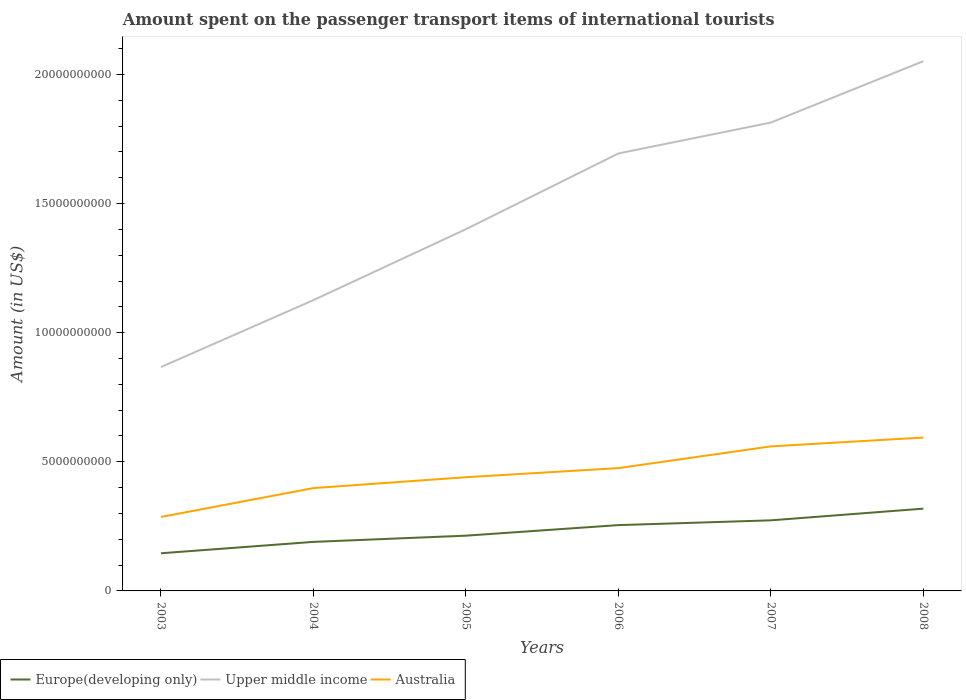Is the number of lines equal to the number of legend labels?
Your answer should be compact. Yes. Across all years, what is the maximum amount spent on the passenger transport items of international tourists in Upper middle income?
Your response must be concise. 8.67e+09. What is the total amount spent on the passenger transport items of international tourists in Australia in the graph?
Offer a very short reply. -1.12e+09. What is the difference between the highest and the second highest amount spent on the passenger transport items of international tourists in Australia?
Make the answer very short. 3.08e+09. Is the amount spent on the passenger transport items of international tourists in Europe(developing only) strictly greater than the amount spent on the passenger transport items of international tourists in Upper middle income over the years?
Keep it short and to the point. Yes. What is the difference between two consecutive major ticks on the Y-axis?
Your answer should be compact. 5.00e+09. Does the graph contain grids?
Provide a short and direct response. No. How many legend labels are there?
Provide a succinct answer. 3. What is the title of the graph?
Ensure brevity in your answer.  Amount spent on the passenger transport items of international tourists. What is the label or title of the X-axis?
Give a very brief answer. Years. What is the Amount (in US$) of Europe(developing only) in 2003?
Give a very brief answer. 1.46e+09. What is the Amount (in US$) of Upper middle income in 2003?
Provide a short and direct response. 8.67e+09. What is the Amount (in US$) in Australia in 2003?
Offer a very short reply. 2.86e+09. What is the Amount (in US$) of Europe(developing only) in 2004?
Keep it short and to the point. 1.90e+09. What is the Amount (in US$) of Upper middle income in 2004?
Ensure brevity in your answer.  1.13e+1. What is the Amount (in US$) in Australia in 2004?
Your answer should be very brief. 3.98e+09. What is the Amount (in US$) in Europe(developing only) in 2005?
Ensure brevity in your answer.  2.14e+09. What is the Amount (in US$) in Upper middle income in 2005?
Your response must be concise. 1.40e+1. What is the Amount (in US$) of Australia in 2005?
Ensure brevity in your answer.  4.40e+09. What is the Amount (in US$) of Europe(developing only) in 2006?
Offer a very short reply. 2.55e+09. What is the Amount (in US$) in Upper middle income in 2006?
Provide a succinct answer. 1.69e+1. What is the Amount (in US$) of Australia in 2006?
Your response must be concise. 4.76e+09. What is the Amount (in US$) in Europe(developing only) in 2007?
Provide a short and direct response. 2.73e+09. What is the Amount (in US$) of Upper middle income in 2007?
Provide a succinct answer. 1.81e+1. What is the Amount (in US$) in Australia in 2007?
Your answer should be compact. 5.60e+09. What is the Amount (in US$) of Europe(developing only) in 2008?
Your answer should be compact. 3.19e+09. What is the Amount (in US$) of Upper middle income in 2008?
Give a very brief answer. 2.05e+1. What is the Amount (in US$) in Australia in 2008?
Offer a very short reply. 5.94e+09. Across all years, what is the maximum Amount (in US$) in Europe(developing only)?
Provide a short and direct response. 3.19e+09. Across all years, what is the maximum Amount (in US$) in Upper middle income?
Your answer should be compact. 2.05e+1. Across all years, what is the maximum Amount (in US$) in Australia?
Your answer should be compact. 5.94e+09. Across all years, what is the minimum Amount (in US$) of Europe(developing only)?
Make the answer very short. 1.46e+09. Across all years, what is the minimum Amount (in US$) in Upper middle income?
Your response must be concise. 8.67e+09. Across all years, what is the minimum Amount (in US$) in Australia?
Provide a short and direct response. 2.86e+09. What is the total Amount (in US$) of Europe(developing only) in the graph?
Provide a succinct answer. 1.40e+1. What is the total Amount (in US$) in Upper middle income in the graph?
Give a very brief answer. 8.95e+1. What is the total Amount (in US$) of Australia in the graph?
Give a very brief answer. 2.75e+1. What is the difference between the Amount (in US$) in Europe(developing only) in 2003 and that in 2004?
Your answer should be very brief. -4.41e+08. What is the difference between the Amount (in US$) in Upper middle income in 2003 and that in 2004?
Provide a short and direct response. -2.59e+09. What is the difference between the Amount (in US$) of Australia in 2003 and that in 2004?
Make the answer very short. -1.12e+09. What is the difference between the Amount (in US$) in Europe(developing only) in 2003 and that in 2005?
Offer a terse response. -6.81e+08. What is the difference between the Amount (in US$) in Upper middle income in 2003 and that in 2005?
Keep it short and to the point. -5.34e+09. What is the difference between the Amount (in US$) of Australia in 2003 and that in 2005?
Provide a short and direct response. -1.54e+09. What is the difference between the Amount (in US$) of Europe(developing only) in 2003 and that in 2006?
Offer a very short reply. -1.09e+09. What is the difference between the Amount (in US$) of Upper middle income in 2003 and that in 2006?
Your response must be concise. -8.27e+09. What is the difference between the Amount (in US$) of Australia in 2003 and that in 2006?
Your answer should be very brief. -1.89e+09. What is the difference between the Amount (in US$) of Europe(developing only) in 2003 and that in 2007?
Make the answer very short. -1.28e+09. What is the difference between the Amount (in US$) of Upper middle income in 2003 and that in 2007?
Provide a succinct answer. -9.47e+09. What is the difference between the Amount (in US$) of Australia in 2003 and that in 2007?
Make the answer very short. -2.73e+09. What is the difference between the Amount (in US$) in Europe(developing only) in 2003 and that in 2008?
Offer a terse response. -1.73e+09. What is the difference between the Amount (in US$) in Upper middle income in 2003 and that in 2008?
Provide a succinct answer. -1.18e+1. What is the difference between the Amount (in US$) of Australia in 2003 and that in 2008?
Give a very brief answer. -3.08e+09. What is the difference between the Amount (in US$) of Europe(developing only) in 2004 and that in 2005?
Provide a short and direct response. -2.40e+08. What is the difference between the Amount (in US$) of Upper middle income in 2004 and that in 2005?
Offer a very short reply. -2.75e+09. What is the difference between the Amount (in US$) of Australia in 2004 and that in 2005?
Your answer should be compact. -4.22e+08. What is the difference between the Amount (in US$) in Europe(developing only) in 2004 and that in 2006?
Offer a terse response. -6.49e+08. What is the difference between the Amount (in US$) in Upper middle income in 2004 and that in 2006?
Make the answer very short. -5.68e+09. What is the difference between the Amount (in US$) of Australia in 2004 and that in 2006?
Keep it short and to the point. -7.74e+08. What is the difference between the Amount (in US$) of Europe(developing only) in 2004 and that in 2007?
Ensure brevity in your answer.  -8.34e+08. What is the difference between the Amount (in US$) of Upper middle income in 2004 and that in 2007?
Your answer should be very brief. -6.88e+09. What is the difference between the Amount (in US$) of Australia in 2004 and that in 2007?
Offer a terse response. -1.62e+09. What is the difference between the Amount (in US$) of Europe(developing only) in 2004 and that in 2008?
Provide a short and direct response. -1.29e+09. What is the difference between the Amount (in US$) of Upper middle income in 2004 and that in 2008?
Your response must be concise. -9.25e+09. What is the difference between the Amount (in US$) of Australia in 2004 and that in 2008?
Provide a succinct answer. -1.96e+09. What is the difference between the Amount (in US$) of Europe(developing only) in 2005 and that in 2006?
Offer a terse response. -4.09e+08. What is the difference between the Amount (in US$) in Upper middle income in 2005 and that in 2006?
Your answer should be very brief. -2.93e+09. What is the difference between the Amount (in US$) of Australia in 2005 and that in 2006?
Keep it short and to the point. -3.52e+08. What is the difference between the Amount (in US$) of Europe(developing only) in 2005 and that in 2007?
Your response must be concise. -5.94e+08. What is the difference between the Amount (in US$) in Upper middle income in 2005 and that in 2007?
Your response must be concise. -4.13e+09. What is the difference between the Amount (in US$) in Australia in 2005 and that in 2007?
Offer a terse response. -1.19e+09. What is the difference between the Amount (in US$) of Europe(developing only) in 2005 and that in 2008?
Provide a succinct answer. -1.05e+09. What is the difference between the Amount (in US$) in Upper middle income in 2005 and that in 2008?
Provide a succinct answer. -6.51e+09. What is the difference between the Amount (in US$) in Australia in 2005 and that in 2008?
Provide a short and direct response. -1.54e+09. What is the difference between the Amount (in US$) in Europe(developing only) in 2006 and that in 2007?
Your answer should be very brief. -1.85e+08. What is the difference between the Amount (in US$) of Upper middle income in 2006 and that in 2007?
Ensure brevity in your answer.  -1.20e+09. What is the difference between the Amount (in US$) in Australia in 2006 and that in 2007?
Your response must be concise. -8.42e+08. What is the difference between the Amount (in US$) in Europe(developing only) in 2006 and that in 2008?
Make the answer very short. -6.38e+08. What is the difference between the Amount (in US$) of Upper middle income in 2006 and that in 2008?
Provide a short and direct response. -3.57e+09. What is the difference between the Amount (in US$) in Australia in 2006 and that in 2008?
Offer a very short reply. -1.18e+09. What is the difference between the Amount (in US$) in Europe(developing only) in 2007 and that in 2008?
Ensure brevity in your answer.  -4.53e+08. What is the difference between the Amount (in US$) of Upper middle income in 2007 and that in 2008?
Provide a succinct answer. -2.38e+09. What is the difference between the Amount (in US$) in Australia in 2007 and that in 2008?
Provide a short and direct response. -3.42e+08. What is the difference between the Amount (in US$) in Europe(developing only) in 2003 and the Amount (in US$) in Upper middle income in 2004?
Your response must be concise. -9.80e+09. What is the difference between the Amount (in US$) in Europe(developing only) in 2003 and the Amount (in US$) in Australia in 2004?
Provide a succinct answer. -2.52e+09. What is the difference between the Amount (in US$) of Upper middle income in 2003 and the Amount (in US$) of Australia in 2004?
Provide a succinct answer. 4.69e+09. What is the difference between the Amount (in US$) of Europe(developing only) in 2003 and the Amount (in US$) of Upper middle income in 2005?
Ensure brevity in your answer.  -1.26e+1. What is the difference between the Amount (in US$) of Europe(developing only) in 2003 and the Amount (in US$) of Australia in 2005?
Your answer should be very brief. -2.95e+09. What is the difference between the Amount (in US$) of Upper middle income in 2003 and the Amount (in US$) of Australia in 2005?
Keep it short and to the point. 4.27e+09. What is the difference between the Amount (in US$) of Europe(developing only) in 2003 and the Amount (in US$) of Upper middle income in 2006?
Provide a short and direct response. -1.55e+1. What is the difference between the Amount (in US$) of Europe(developing only) in 2003 and the Amount (in US$) of Australia in 2006?
Offer a terse response. -3.30e+09. What is the difference between the Amount (in US$) in Upper middle income in 2003 and the Amount (in US$) in Australia in 2006?
Offer a very short reply. 3.91e+09. What is the difference between the Amount (in US$) in Europe(developing only) in 2003 and the Amount (in US$) in Upper middle income in 2007?
Give a very brief answer. -1.67e+1. What is the difference between the Amount (in US$) of Europe(developing only) in 2003 and the Amount (in US$) of Australia in 2007?
Keep it short and to the point. -4.14e+09. What is the difference between the Amount (in US$) of Upper middle income in 2003 and the Amount (in US$) of Australia in 2007?
Your response must be concise. 3.07e+09. What is the difference between the Amount (in US$) in Europe(developing only) in 2003 and the Amount (in US$) in Upper middle income in 2008?
Your answer should be very brief. -1.91e+1. What is the difference between the Amount (in US$) in Europe(developing only) in 2003 and the Amount (in US$) in Australia in 2008?
Give a very brief answer. -4.48e+09. What is the difference between the Amount (in US$) of Upper middle income in 2003 and the Amount (in US$) of Australia in 2008?
Ensure brevity in your answer.  2.73e+09. What is the difference between the Amount (in US$) of Europe(developing only) in 2004 and the Amount (in US$) of Upper middle income in 2005?
Provide a short and direct response. -1.21e+1. What is the difference between the Amount (in US$) of Europe(developing only) in 2004 and the Amount (in US$) of Australia in 2005?
Offer a very short reply. -2.50e+09. What is the difference between the Amount (in US$) of Upper middle income in 2004 and the Amount (in US$) of Australia in 2005?
Your response must be concise. 6.86e+09. What is the difference between the Amount (in US$) of Europe(developing only) in 2004 and the Amount (in US$) of Upper middle income in 2006?
Offer a terse response. -1.50e+1. What is the difference between the Amount (in US$) in Europe(developing only) in 2004 and the Amount (in US$) in Australia in 2006?
Offer a terse response. -2.86e+09. What is the difference between the Amount (in US$) of Upper middle income in 2004 and the Amount (in US$) of Australia in 2006?
Keep it short and to the point. 6.51e+09. What is the difference between the Amount (in US$) in Europe(developing only) in 2004 and the Amount (in US$) in Upper middle income in 2007?
Provide a succinct answer. -1.62e+1. What is the difference between the Amount (in US$) in Europe(developing only) in 2004 and the Amount (in US$) in Australia in 2007?
Offer a very short reply. -3.70e+09. What is the difference between the Amount (in US$) in Upper middle income in 2004 and the Amount (in US$) in Australia in 2007?
Your answer should be very brief. 5.66e+09. What is the difference between the Amount (in US$) in Europe(developing only) in 2004 and the Amount (in US$) in Upper middle income in 2008?
Make the answer very short. -1.86e+1. What is the difference between the Amount (in US$) in Europe(developing only) in 2004 and the Amount (in US$) in Australia in 2008?
Your answer should be compact. -4.04e+09. What is the difference between the Amount (in US$) of Upper middle income in 2004 and the Amount (in US$) of Australia in 2008?
Your answer should be compact. 5.32e+09. What is the difference between the Amount (in US$) of Europe(developing only) in 2005 and the Amount (in US$) of Upper middle income in 2006?
Your answer should be very brief. -1.48e+1. What is the difference between the Amount (in US$) in Europe(developing only) in 2005 and the Amount (in US$) in Australia in 2006?
Provide a succinct answer. -2.62e+09. What is the difference between the Amount (in US$) in Upper middle income in 2005 and the Amount (in US$) in Australia in 2006?
Make the answer very short. 9.25e+09. What is the difference between the Amount (in US$) of Europe(developing only) in 2005 and the Amount (in US$) of Upper middle income in 2007?
Ensure brevity in your answer.  -1.60e+1. What is the difference between the Amount (in US$) in Europe(developing only) in 2005 and the Amount (in US$) in Australia in 2007?
Keep it short and to the point. -3.46e+09. What is the difference between the Amount (in US$) in Upper middle income in 2005 and the Amount (in US$) in Australia in 2007?
Keep it short and to the point. 8.41e+09. What is the difference between the Amount (in US$) of Europe(developing only) in 2005 and the Amount (in US$) of Upper middle income in 2008?
Your response must be concise. -1.84e+1. What is the difference between the Amount (in US$) of Europe(developing only) in 2005 and the Amount (in US$) of Australia in 2008?
Offer a terse response. -3.80e+09. What is the difference between the Amount (in US$) of Upper middle income in 2005 and the Amount (in US$) of Australia in 2008?
Offer a very short reply. 8.07e+09. What is the difference between the Amount (in US$) in Europe(developing only) in 2006 and the Amount (in US$) in Upper middle income in 2007?
Your answer should be very brief. -1.56e+1. What is the difference between the Amount (in US$) in Europe(developing only) in 2006 and the Amount (in US$) in Australia in 2007?
Keep it short and to the point. -3.05e+09. What is the difference between the Amount (in US$) of Upper middle income in 2006 and the Amount (in US$) of Australia in 2007?
Your answer should be compact. 1.13e+1. What is the difference between the Amount (in US$) in Europe(developing only) in 2006 and the Amount (in US$) in Upper middle income in 2008?
Your answer should be compact. -1.80e+1. What is the difference between the Amount (in US$) in Europe(developing only) in 2006 and the Amount (in US$) in Australia in 2008?
Your answer should be very brief. -3.39e+09. What is the difference between the Amount (in US$) in Upper middle income in 2006 and the Amount (in US$) in Australia in 2008?
Provide a short and direct response. 1.10e+1. What is the difference between the Amount (in US$) in Europe(developing only) in 2007 and the Amount (in US$) in Upper middle income in 2008?
Give a very brief answer. -1.78e+1. What is the difference between the Amount (in US$) in Europe(developing only) in 2007 and the Amount (in US$) in Australia in 2008?
Ensure brevity in your answer.  -3.21e+09. What is the difference between the Amount (in US$) in Upper middle income in 2007 and the Amount (in US$) in Australia in 2008?
Offer a very short reply. 1.22e+1. What is the average Amount (in US$) in Europe(developing only) per year?
Ensure brevity in your answer.  2.33e+09. What is the average Amount (in US$) of Upper middle income per year?
Provide a succinct answer. 1.49e+1. What is the average Amount (in US$) in Australia per year?
Keep it short and to the point. 4.59e+09. In the year 2003, what is the difference between the Amount (in US$) in Europe(developing only) and Amount (in US$) in Upper middle income?
Keep it short and to the point. -7.21e+09. In the year 2003, what is the difference between the Amount (in US$) in Europe(developing only) and Amount (in US$) in Australia?
Provide a short and direct response. -1.41e+09. In the year 2003, what is the difference between the Amount (in US$) of Upper middle income and Amount (in US$) of Australia?
Your answer should be very brief. 5.80e+09. In the year 2004, what is the difference between the Amount (in US$) in Europe(developing only) and Amount (in US$) in Upper middle income?
Make the answer very short. -9.36e+09. In the year 2004, what is the difference between the Amount (in US$) in Europe(developing only) and Amount (in US$) in Australia?
Keep it short and to the point. -2.08e+09. In the year 2004, what is the difference between the Amount (in US$) of Upper middle income and Amount (in US$) of Australia?
Provide a short and direct response. 7.28e+09. In the year 2005, what is the difference between the Amount (in US$) of Europe(developing only) and Amount (in US$) of Upper middle income?
Keep it short and to the point. -1.19e+1. In the year 2005, what is the difference between the Amount (in US$) of Europe(developing only) and Amount (in US$) of Australia?
Provide a short and direct response. -2.26e+09. In the year 2005, what is the difference between the Amount (in US$) in Upper middle income and Amount (in US$) in Australia?
Offer a terse response. 9.61e+09. In the year 2006, what is the difference between the Amount (in US$) in Europe(developing only) and Amount (in US$) in Upper middle income?
Your answer should be compact. -1.44e+1. In the year 2006, what is the difference between the Amount (in US$) in Europe(developing only) and Amount (in US$) in Australia?
Your response must be concise. -2.21e+09. In the year 2006, what is the difference between the Amount (in US$) of Upper middle income and Amount (in US$) of Australia?
Your response must be concise. 1.22e+1. In the year 2007, what is the difference between the Amount (in US$) in Europe(developing only) and Amount (in US$) in Upper middle income?
Provide a short and direct response. -1.54e+1. In the year 2007, what is the difference between the Amount (in US$) in Europe(developing only) and Amount (in US$) in Australia?
Give a very brief answer. -2.86e+09. In the year 2007, what is the difference between the Amount (in US$) in Upper middle income and Amount (in US$) in Australia?
Make the answer very short. 1.25e+1. In the year 2008, what is the difference between the Amount (in US$) of Europe(developing only) and Amount (in US$) of Upper middle income?
Give a very brief answer. -1.73e+1. In the year 2008, what is the difference between the Amount (in US$) of Europe(developing only) and Amount (in US$) of Australia?
Keep it short and to the point. -2.75e+09. In the year 2008, what is the difference between the Amount (in US$) in Upper middle income and Amount (in US$) in Australia?
Ensure brevity in your answer.  1.46e+1. What is the ratio of the Amount (in US$) of Europe(developing only) in 2003 to that in 2004?
Your response must be concise. 0.77. What is the ratio of the Amount (in US$) of Upper middle income in 2003 to that in 2004?
Your answer should be very brief. 0.77. What is the ratio of the Amount (in US$) of Australia in 2003 to that in 2004?
Keep it short and to the point. 0.72. What is the ratio of the Amount (in US$) of Europe(developing only) in 2003 to that in 2005?
Keep it short and to the point. 0.68. What is the ratio of the Amount (in US$) in Upper middle income in 2003 to that in 2005?
Keep it short and to the point. 0.62. What is the ratio of the Amount (in US$) in Australia in 2003 to that in 2005?
Keep it short and to the point. 0.65. What is the ratio of the Amount (in US$) in Europe(developing only) in 2003 to that in 2006?
Give a very brief answer. 0.57. What is the ratio of the Amount (in US$) of Upper middle income in 2003 to that in 2006?
Your response must be concise. 0.51. What is the ratio of the Amount (in US$) in Australia in 2003 to that in 2006?
Your answer should be very brief. 0.6. What is the ratio of the Amount (in US$) in Europe(developing only) in 2003 to that in 2007?
Your response must be concise. 0.53. What is the ratio of the Amount (in US$) in Upper middle income in 2003 to that in 2007?
Give a very brief answer. 0.48. What is the ratio of the Amount (in US$) in Australia in 2003 to that in 2007?
Offer a terse response. 0.51. What is the ratio of the Amount (in US$) in Europe(developing only) in 2003 to that in 2008?
Ensure brevity in your answer.  0.46. What is the ratio of the Amount (in US$) of Upper middle income in 2003 to that in 2008?
Provide a short and direct response. 0.42. What is the ratio of the Amount (in US$) in Australia in 2003 to that in 2008?
Your response must be concise. 0.48. What is the ratio of the Amount (in US$) in Europe(developing only) in 2004 to that in 2005?
Provide a succinct answer. 0.89. What is the ratio of the Amount (in US$) in Upper middle income in 2004 to that in 2005?
Offer a very short reply. 0.8. What is the ratio of the Amount (in US$) of Australia in 2004 to that in 2005?
Give a very brief answer. 0.9. What is the ratio of the Amount (in US$) of Europe(developing only) in 2004 to that in 2006?
Offer a very short reply. 0.75. What is the ratio of the Amount (in US$) in Upper middle income in 2004 to that in 2006?
Make the answer very short. 0.66. What is the ratio of the Amount (in US$) in Australia in 2004 to that in 2006?
Provide a succinct answer. 0.84. What is the ratio of the Amount (in US$) in Europe(developing only) in 2004 to that in 2007?
Offer a terse response. 0.69. What is the ratio of the Amount (in US$) in Upper middle income in 2004 to that in 2007?
Provide a short and direct response. 0.62. What is the ratio of the Amount (in US$) of Australia in 2004 to that in 2007?
Offer a terse response. 0.71. What is the ratio of the Amount (in US$) of Europe(developing only) in 2004 to that in 2008?
Your response must be concise. 0.6. What is the ratio of the Amount (in US$) in Upper middle income in 2004 to that in 2008?
Your answer should be very brief. 0.55. What is the ratio of the Amount (in US$) of Australia in 2004 to that in 2008?
Offer a terse response. 0.67. What is the ratio of the Amount (in US$) of Europe(developing only) in 2005 to that in 2006?
Give a very brief answer. 0.84. What is the ratio of the Amount (in US$) of Upper middle income in 2005 to that in 2006?
Offer a terse response. 0.83. What is the ratio of the Amount (in US$) of Australia in 2005 to that in 2006?
Offer a very short reply. 0.93. What is the ratio of the Amount (in US$) of Europe(developing only) in 2005 to that in 2007?
Provide a short and direct response. 0.78. What is the ratio of the Amount (in US$) in Upper middle income in 2005 to that in 2007?
Give a very brief answer. 0.77. What is the ratio of the Amount (in US$) in Australia in 2005 to that in 2007?
Your answer should be very brief. 0.79. What is the ratio of the Amount (in US$) of Europe(developing only) in 2005 to that in 2008?
Your answer should be compact. 0.67. What is the ratio of the Amount (in US$) of Upper middle income in 2005 to that in 2008?
Your answer should be very brief. 0.68. What is the ratio of the Amount (in US$) of Australia in 2005 to that in 2008?
Keep it short and to the point. 0.74. What is the ratio of the Amount (in US$) in Europe(developing only) in 2006 to that in 2007?
Ensure brevity in your answer.  0.93. What is the ratio of the Amount (in US$) in Upper middle income in 2006 to that in 2007?
Make the answer very short. 0.93. What is the ratio of the Amount (in US$) in Australia in 2006 to that in 2007?
Your answer should be very brief. 0.85. What is the ratio of the Amount (in US$) of Europe(developing only) in 2006 to that in 2008?
Provide a short and direct response. 0.8. What is the ratio of the Amount (in US$) in Upper middle income in 2006 to that in 2008?
Keep it short and to the point. 0.83. What is the ratio of the Amount (in US$) in Australia in 2006 to that in 2008?
Make the answer very short. 0.8. What is the ratio of the Amount (in US$) of Europe(developing only) in 2007 to that in 2008?
Ensure brevity in your answer.  0.86. What is the ratio of the Amount (in US$) of Upper middle income in 2007 to that in 2008?
Offer a very short reply. 0.88. What is the ratio of the Amount (in US$) in Australia in 2007 to that in 2008?
Provide a short and direct response. 0.94. What is the difference between the highest and the second highest Amount (in US$) of Europe(developing only)?
Your response must be concise. 4.53e+08. What is the difference between the highest and the second highest Amount (in US$) in Upper middle income?
Provide a short and direct response. 2.38e+09. What is the difference between the highest and the second highest Amount (in US$) in Australia?
Keep it short and to the point. 3.42e+08. What is the difference between the highest and the lowest Amount (in US$) of Europe(developing only)?
Your answer should be very brief. 1.73e+09. What is the difference between the highest and the lowest Amount (in US$) in Upper middle income?
Offer a terse response. 1.18e+1. What is the difference between the highest and the lowest Amount (in US$) in Australia?
Offer a very short reply. 3.08e+09. 